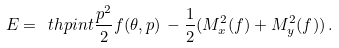Convert formula to latex. <formula><loc_0><loc_0><loc_500><loc_500>E = \ t h p i n t \frac { p ^ { 2 } } { 2 } f ( \theta , p ) \, - \frac { 1 } { 2 } ( M _ { x } ^ { 2 } ( f ) + M _ { y } ^ { 2 } ( f ) ) \, .</formula> 